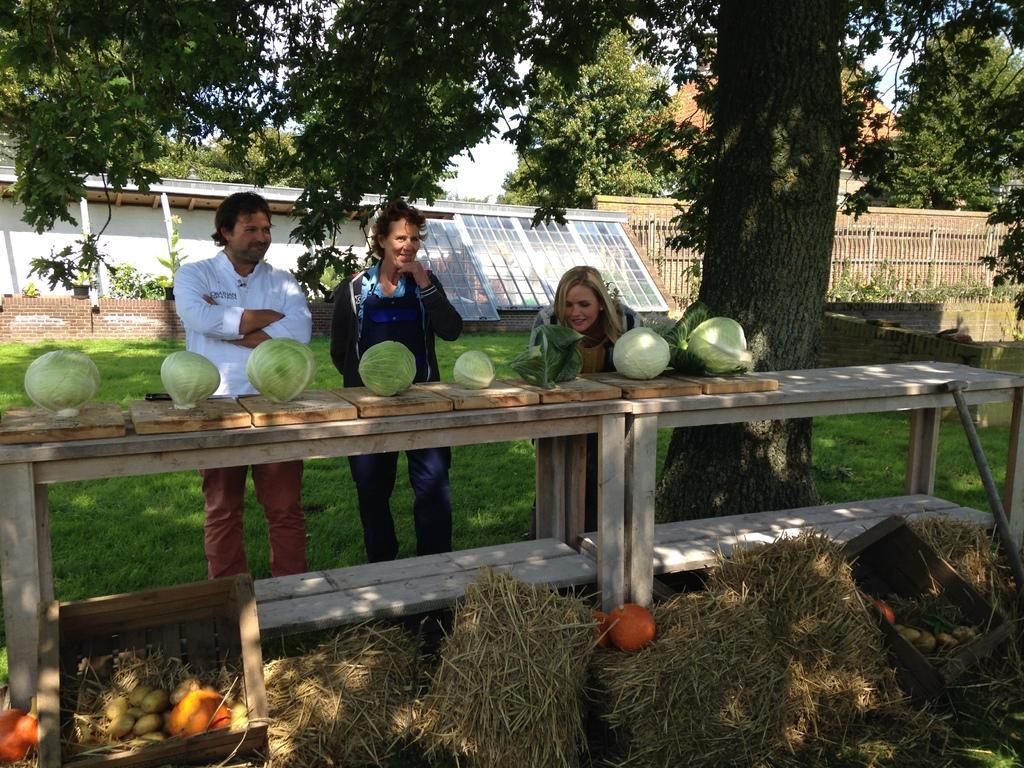Please provide a concise description of this image. This image consists of a three persons. In front of them there is a table on which, we can see many cabbage. On the right, there is a tree. In the background, we can see a wall and a fencing. In the At the bottom, there is dry grass. 